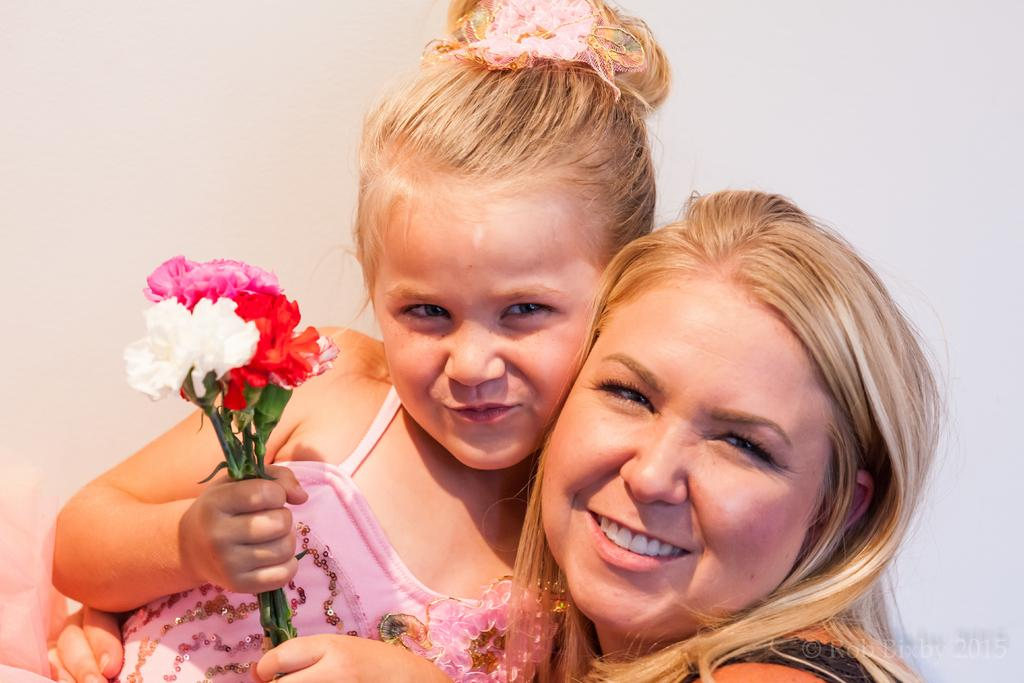Who is the main subject in the image? There is a girl in the image. What is the girl holding in the image? The girl is holding a bunch of flowers. What is the girl doing in the image? The girl is laying on another person. Is there any additional information about the image itself? Yes, there is a watermark on the image. How many apples are being transported by the light in the image? There are no apples or light present in the image. 